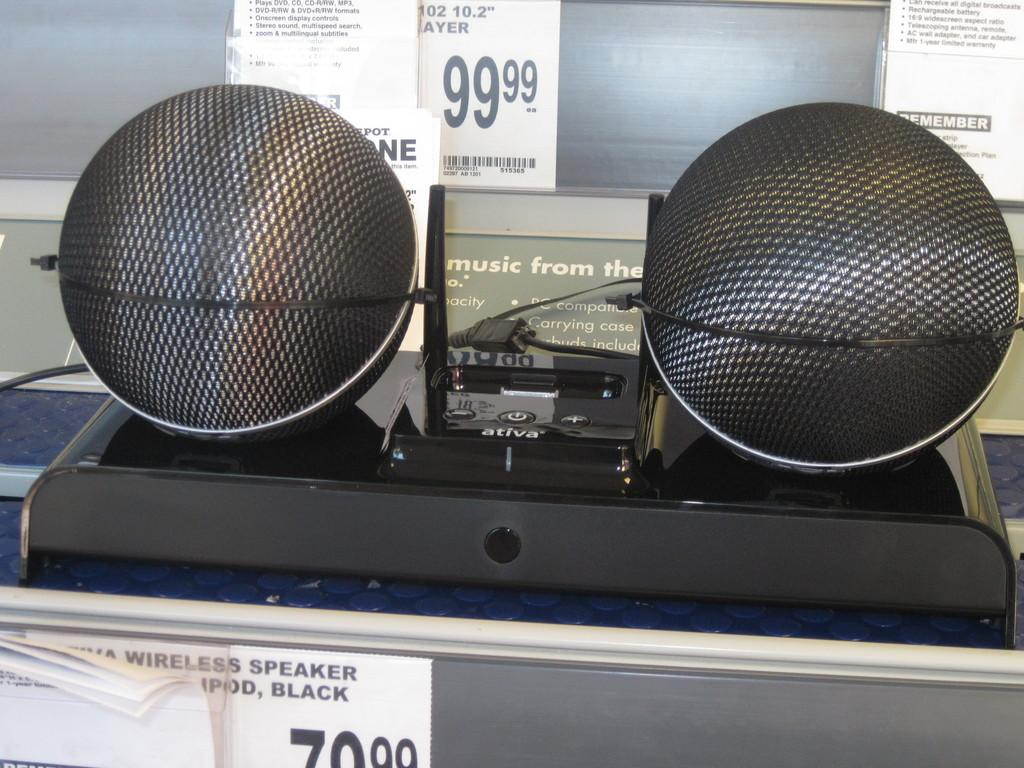What is located on the platform in the image? There are speakers on a platform in the image. What else can be seen in the image besides the speakers? There are posters in the image. What type of material is visible in the background of the image? There is a background with glass visible in the image. Can you see a dog looking out the glass in the image? There is no dog present in the image, and the glass is not a window or aperture through which a dog could be looking. 